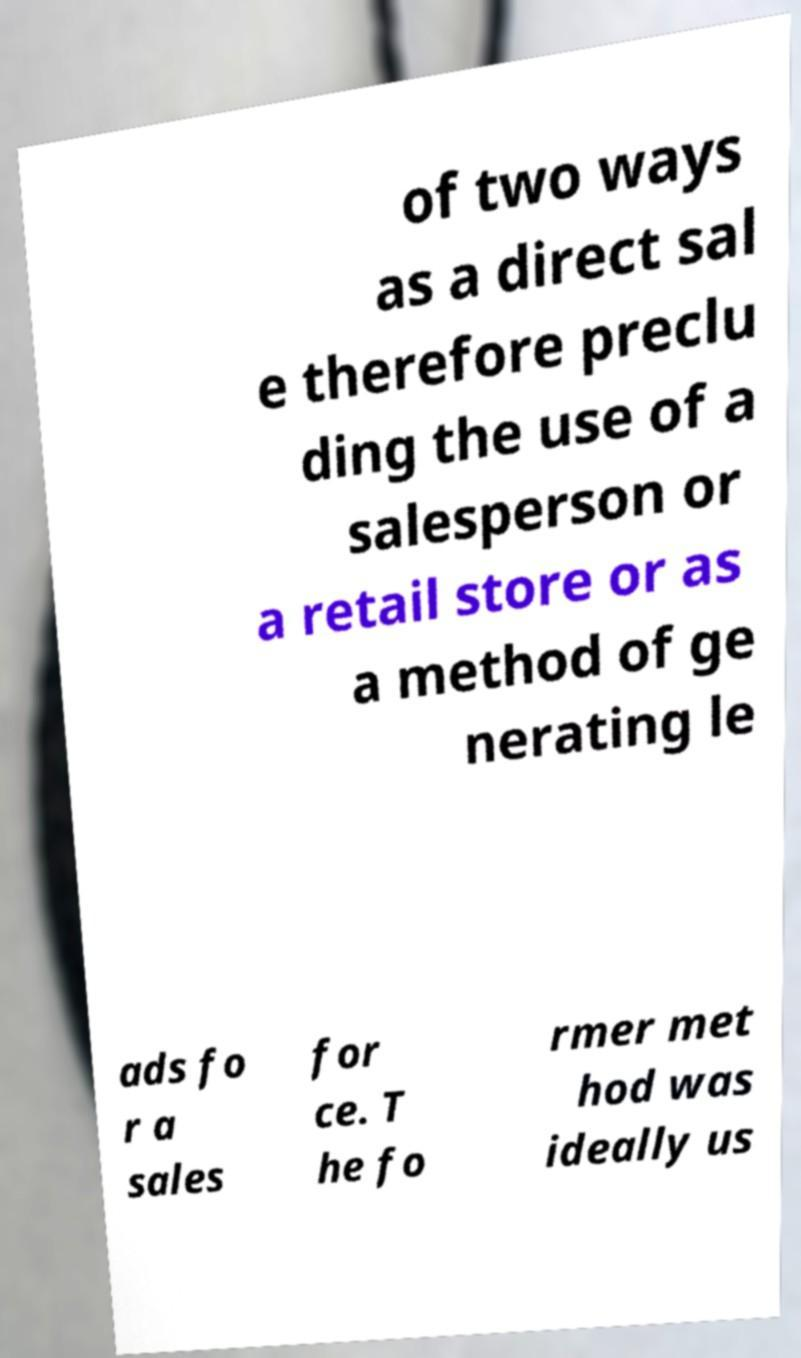Can you accurately transcribe the text from the provided image for me? of two ways as a direct sal e therefore preclu ding the use of a salesperson or a retail store or as a method of ge nerating le ads fo r a sales for ce. T he fo rmer met hod was ideally us 